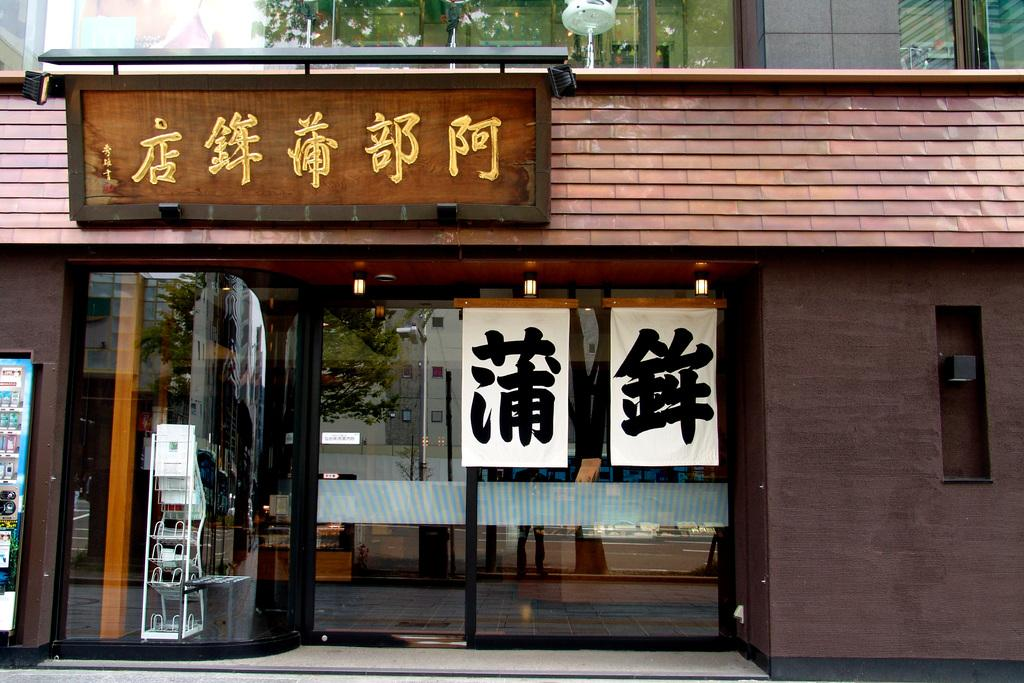What type of establishment is depicted in the image? There is a store in the image. How can customers enter the store? The store has a door. What is displayed outside the store? The store has a board and a stand. Can you describe any other objects present in the store? There are other objects in the store, but their specific details are not mentioned in the provided facts. What type of zephyr can be seen blowing through the store in the image? There is no mention of a zephyr in the image, so it cannot be determined if one is present. What type of tray is used to serve popcorn in the store? There is no mention of popcorn or a tray in the image, so it cannot be determined if one is present. 